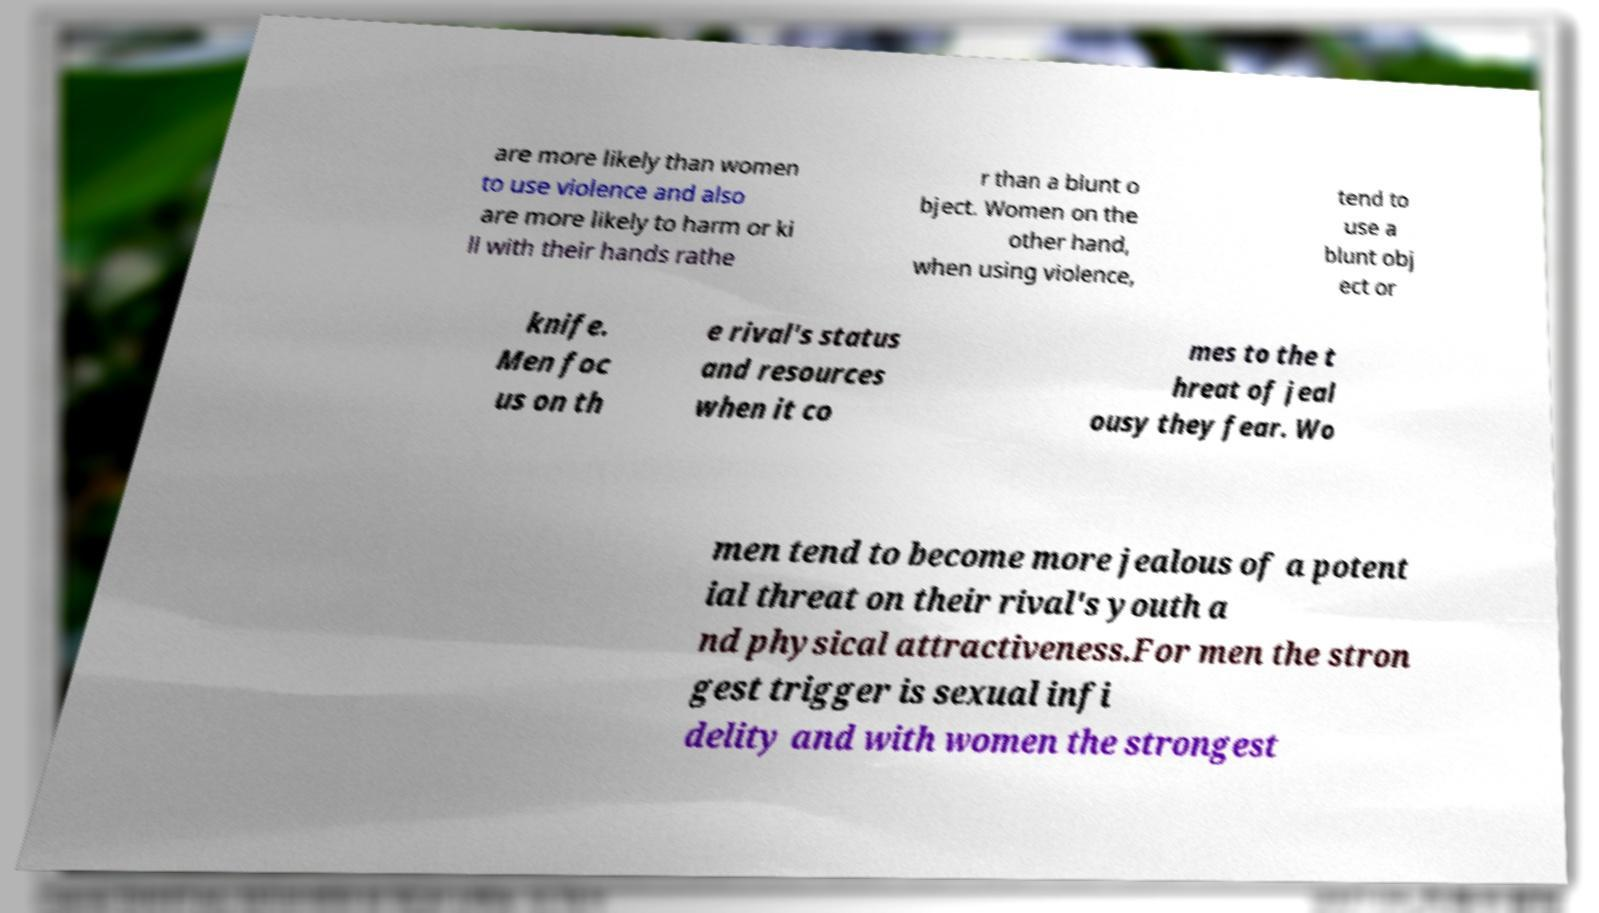For documentation purposes, I need the text within this image transcribed. Could you provide that? are more likely than women to use violence and also are more likely to harm or ki ll with their hands rathe r than a blunt o bject. Women on the other hand, when using violence, tend to use a blunt obj ect or knife. Men foc us on th e rival's status and resources when it co mes to the t hreat of jeal ousy they fear. Wo men tend to become more jealous of a potent ial threat on their rival's youth a nd physical attractiveness.For men the stron gest trigger is sexual infi delity and with women the strongest 